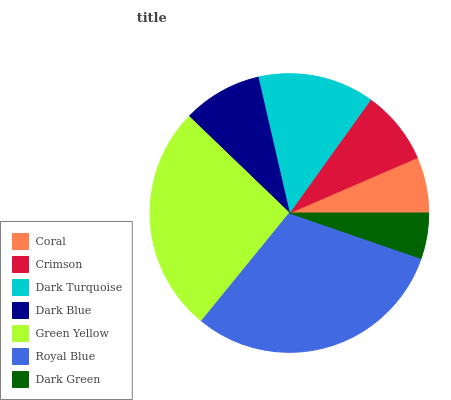Is Dark Green the minimum?
Answer yes or no. Yes. Is Royal Blue the maximum?
Answer yes or no. Yes. Is Crimson the minimum?
Answer yes or no. No. Is Crimson the maximum?
Answer yes or no. No. Is Crimson greater than Coral?
Answer yes or no. Yes. Is Coral less than Crimson?
Answer yes or no. Yes. Is Coral greater than Crimson?
Answer yes or no. No. Is Crimson less than Coral?
Answer yes or no. No. Is Dark Blue the high median?
Answer yes or no. Yes. Is Dark Blue the low median?
Answer yes or no. Yes. Is Dark Green the high median?
Answer yes or no. No. Is Royal Blue the low median?
Answer yes or no. No. 